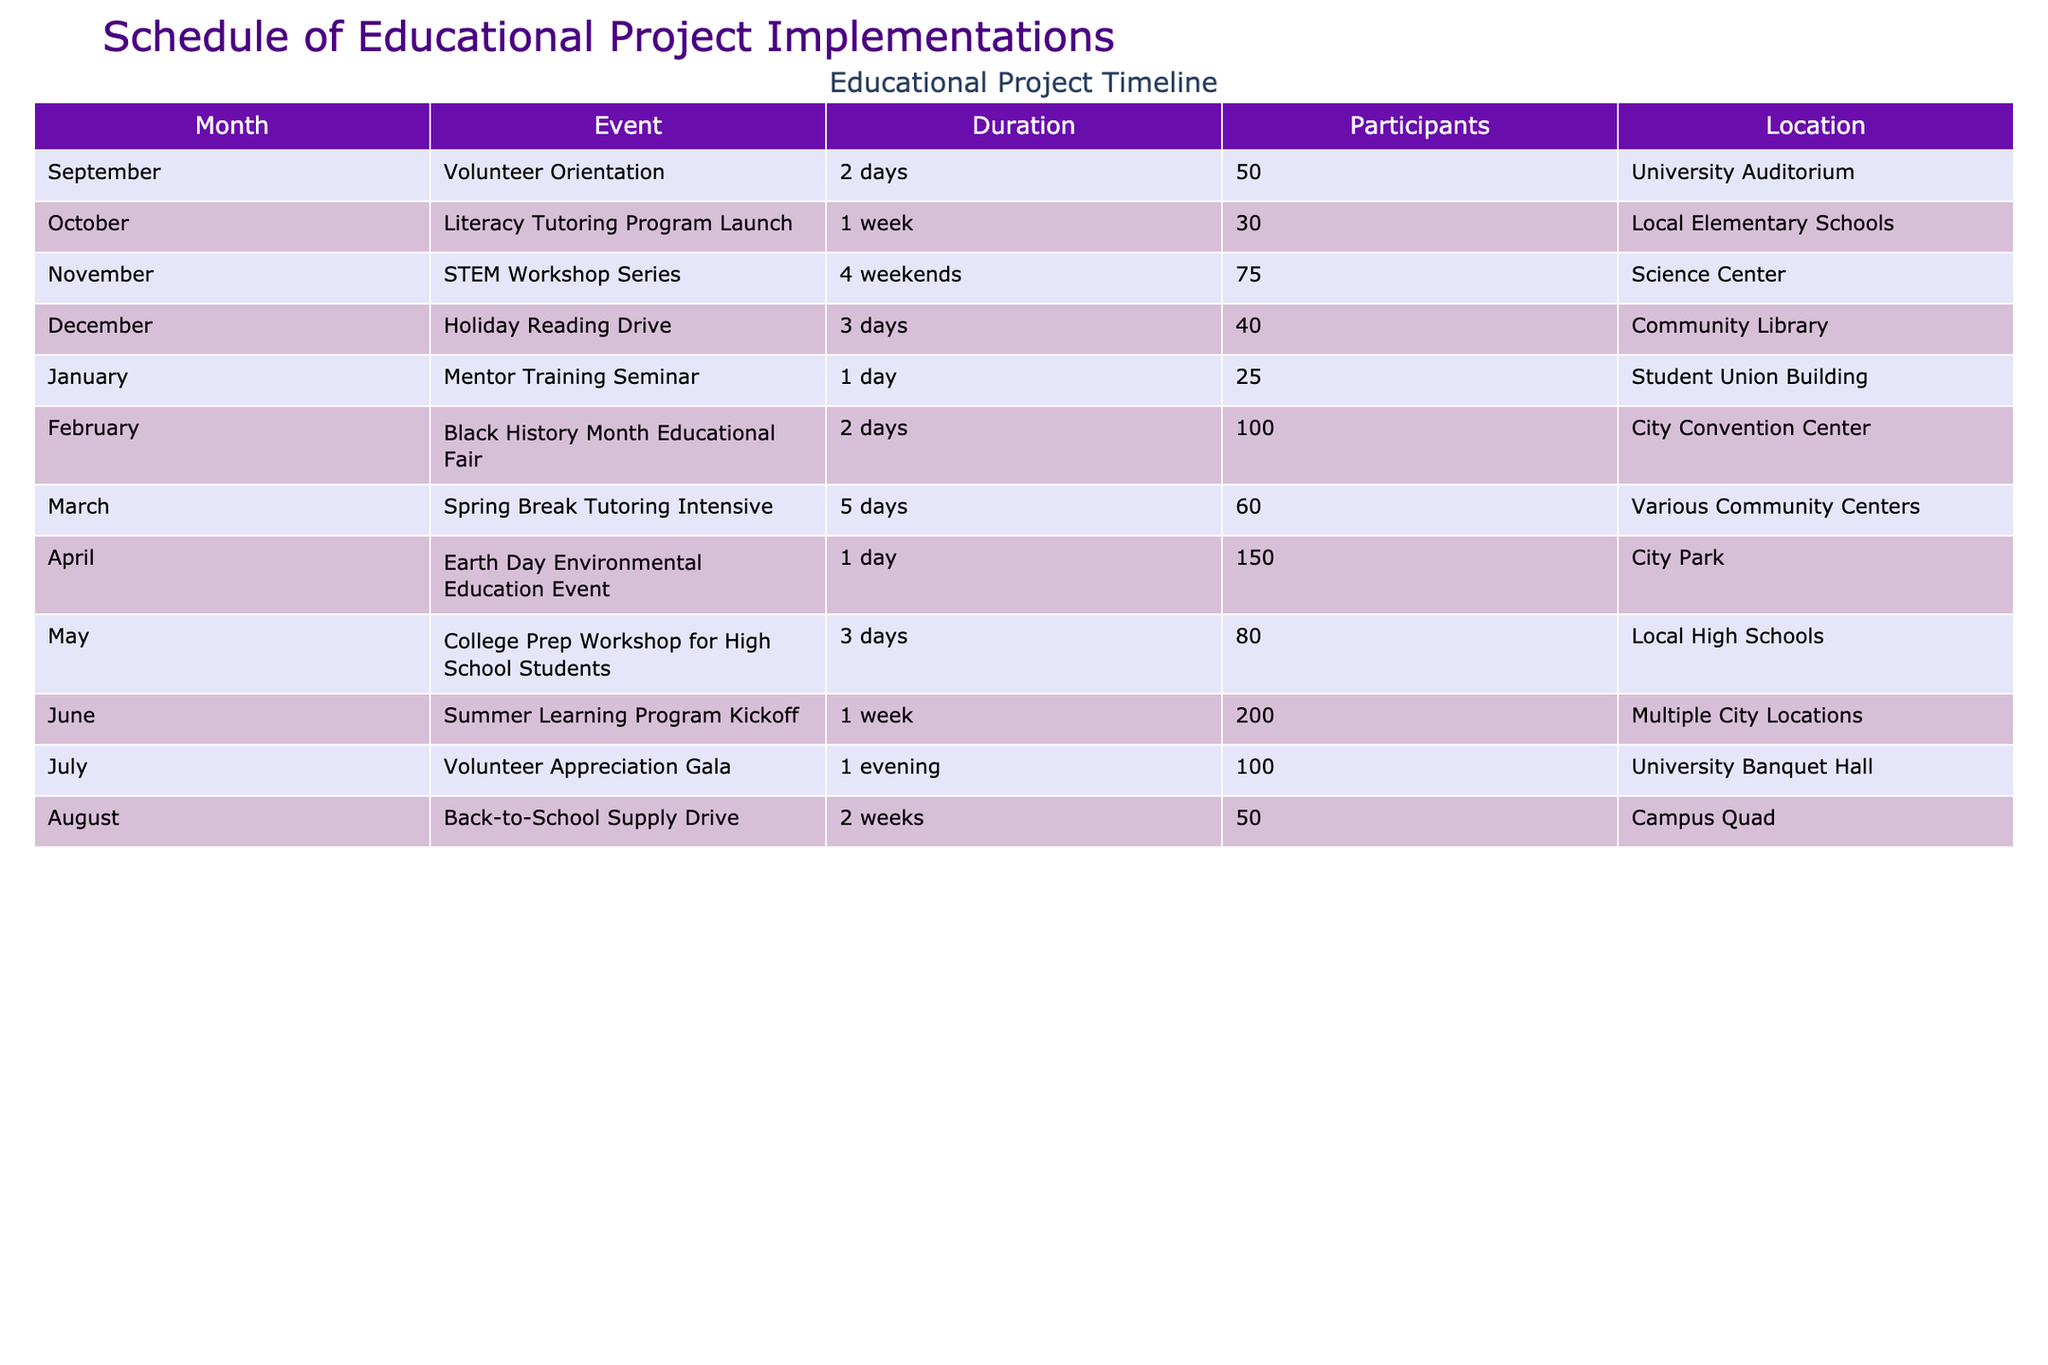What month does the Holiday Reading Drive take place? The table shows that the Holiday Reading Drive event is scheduled for December.
Answer: December How long does the Earth Day Environmental Education Event last? The table specifies that the Earth Day Environmental Education Event is a one-day event.
Answer: 1 day What is the total number of participants for the Literacy Tutoring Program and the Mentor Training Seminar? From the table, the Literacy Tutoring Program has 30 participants, and the Mentor Training Seminar has 25 participants. So, the total is 30 + 25 = 55 participants.
Answer: 55 In which location is the Black History Month Educational Fair held? The table indicates that the Black History Month Educational Fair takes place at the City Convention Center.
Answer: City Convention Center Is the Summer Learning Program Kickoff scheduled for one week? Yes, the table states that the Summer Learning Program Kickoff has a duration of one week.
Answer: Yes What is the average number of participants for events in the month of June and July? From the table, the Summer Learning Program Kickoff in June has 200 participants, and the Volunteer Appreciation Gala in July has 100 participants. The average is (200 + 100) / 2 = 150.
Answer: 150 How many weekends does the STEM Workshop Series span? The table shows that the STEM Workshop Series lasts for 4 weekends.
Answer: 4 weekends How many days does the Back-to-School Supply Drive last? According to the table, the Back-to-School Supply Drive lasts for two weeks, which is equivalent to 14 days.
Answer: 14 days Which event has the highest number of participants, and what is that number? By reviewing the table, the Summer Learning Program Kickoff has the highest number of participants, totaling 200.
Answer: 200 